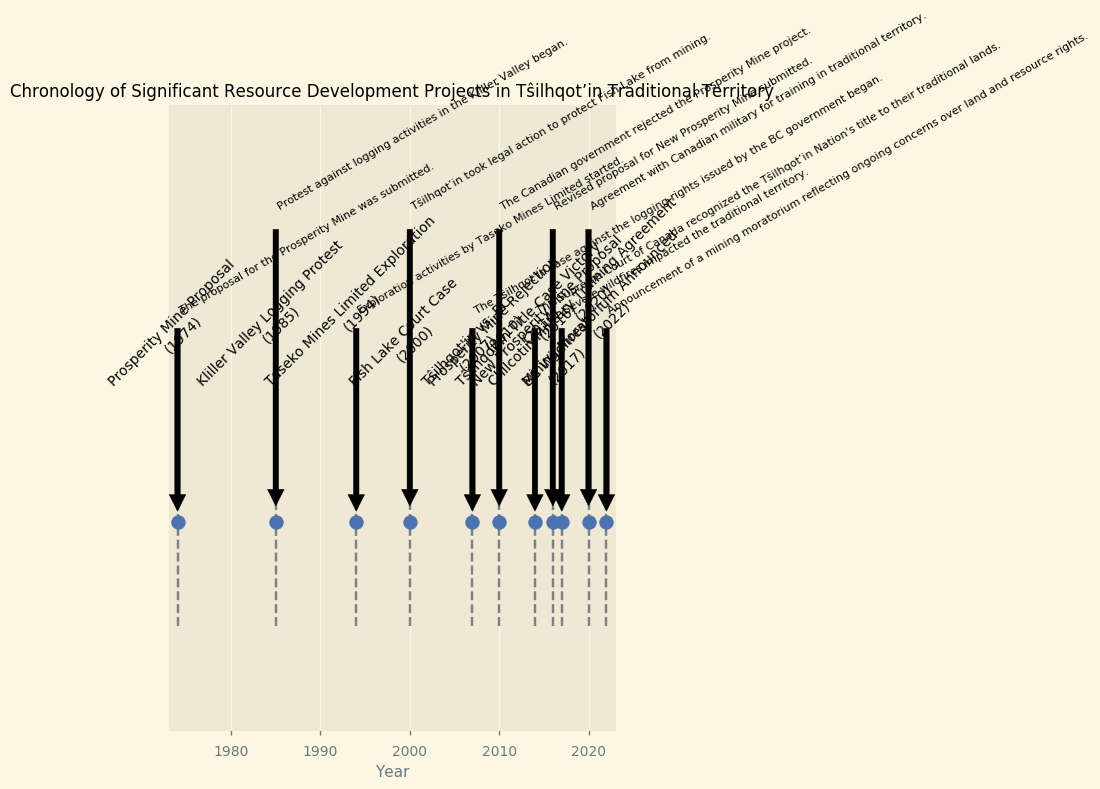What year was the proposal for the Prosperity Mine submitted? According to the figure, the Prosperity Mine Proposal is marked in the year 1974.
Answer: 1974 Which event occurred first, the Tŝilhqot’in vs. BC case or the Fish Lake Court Case? By referring to the chronological order of events in the figure, the Fish Lake Court Case occurred in 2000, and the Tŝilhqot’in vs. BC case started in 2007. Therefore, the Fish Lake Court Case occurred first.
Answer: Fish Lake Court Case How many years after the original Prosperity Mine proposal was the New Prosperity Mine proposal submitted? The original Prosperity Mine Proposal was submitted in 1974, and the New Prosperity Mine Proposal was submitted in 2016. The difference between 2016 and 1974 is 42 years.
Answer: 42 years What is the relationship between the Prosperity Mine Rejection and the New Prosperity Mine Proposal regarding their timeline? The Prosperity Mine Rejection by the Canadian government occurred in 2010, and the revised New Prosperity Mine Proposal was submitted in 2016. This indicates a span of 6 years between these two events.
Answer: 6 years apart Which event is visually marked closest to the middle of the timeline? By examining the plot visually, the Tŝilhqot’in Title Case Victory in 2014 appears closest to the middle of the timeline when considering the range from 1974 to 2022.
Answer: Tŝilhqot’in Title Case Victory Which event occurred immediately after the Kliller Valley Logging Protest? The Kliller Valley Logging Protest occurred in 1985. The next event on the timeline is the Taseko Mines Limited Exploration starting in 1994.
Answer: Taseko Mines Limited Exploration How many years before the Mining Moratorium was the Chilcotin Military Training Agreement signed? The Mining Moratorium was announced in 2022, and the Chilcotin Military Training Agreement was signed in 2020. The difference is 2 years.
Answer: 2 years Between which two events was there a significant wildfire in the Tŝilhqot’in Traditional Territory? The BC Wildfires occurred in 2017. The prior event was the New Prosperity Mine Proposal in 2016, and the subsequent event was the Chilcotin Military Training Agreement in 2020.
Answer: New Prosperity Mine Proposal and Chilcotin Military Training Agreement What major legal victory did the Tŝilhqot’in Nation achieve in 2014 and how does it visually indicate its importance? In 2014, the Tŝilhqot’in Title Case Victory occurred, where the Supreme Court of Canada recognized the Tŝilhqot’in Nation's title to their traditional lands. This event is prominently labeled in the figure, indicating its importance.
Answer: Tŝilhqot’in Title Case Victory in 2014 